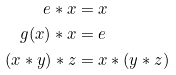Convert formula to latex. <formula><loc_0><loc_0><loc_500><loc_500>e * x & = x \\ g ( x ) * x & = e \\ ( x * y ) * z & = x * ( y * z )</formula> 